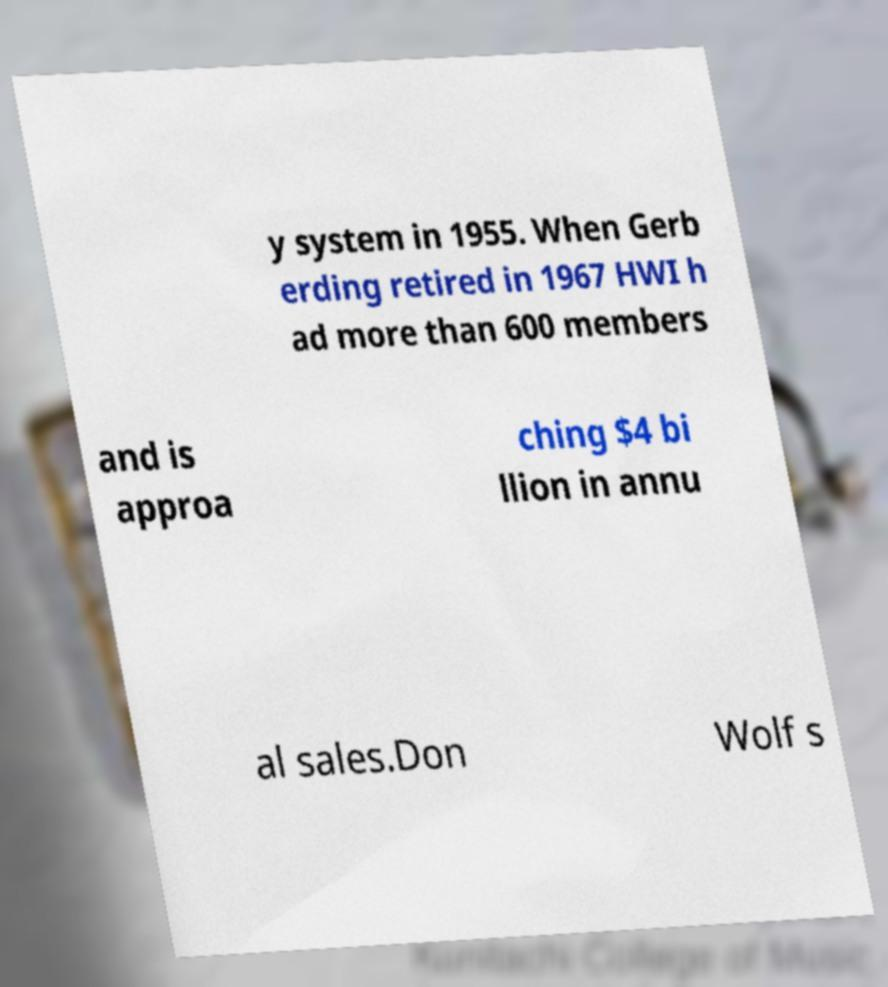Please read and relay the text visible in this image. What does it say? y system in 1955. When Gerb erding retired in 1967 HWI h ad more than 600 members and is approa ching $4 bi llion in annu al sales.Don Wolf s 